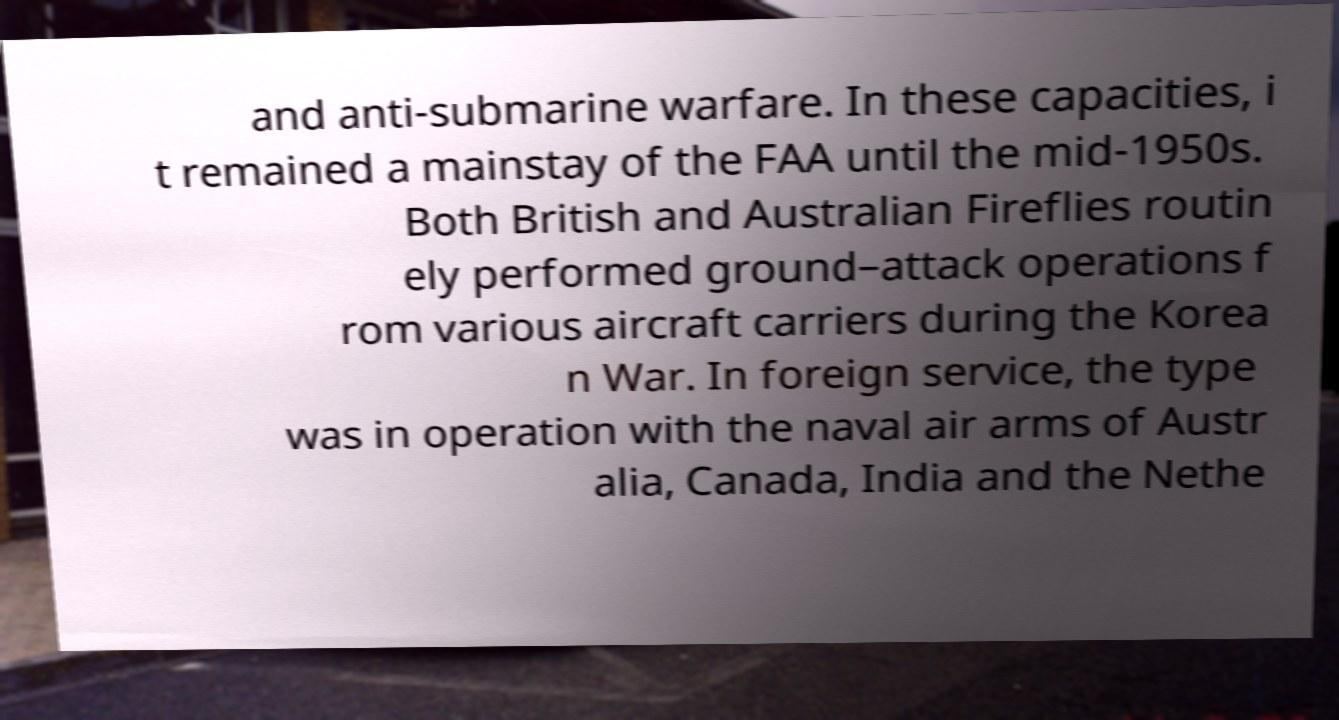Could you assist in decoding the text presented in this image and type it out clearly? and anti-submarine warfare. In these capacities, i t remained a mainstay of the FAA until the mid-1950s. Both British and Australian Fireflies routin ely performed ground–attack operations f rom various aircraft carriers during the Korea n War. In foreign service, the type was in operation with the naval air arms of Austr alia, Canada, India and the Nethe 